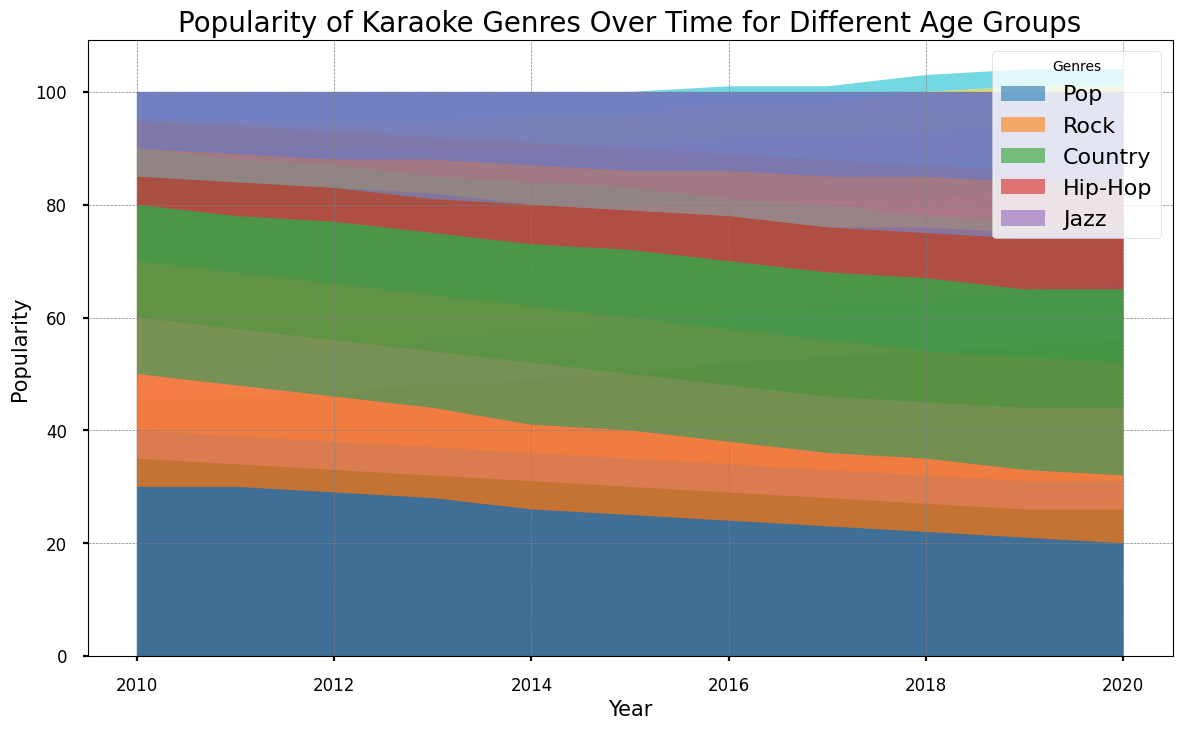What genre is most popular among the 25-34 age group in the year 2020? The genre that has the largest area within the segment for the 25-34 age group in 2020 is the most popular. By checking the stacked area, Pop has the largest representation.
Answer: Pop How did Pop's popularity change for the 18-24 age group from 2010 to 2020? By looking at the height of the Pop segment for the 18-24 age group in 2010 and comparing it to 2020, we see that it increased from approximately 50 to 66.
Answer: Increased Which age group showed the highest popularity for Jazz in 2020? By examining the segments for Jazz in 2020 across all age groups, the 55+ age group has the tallest Jazz segment.
Answer: 55+ What is the combined popularity of Rock and Country for the 35-44 age group in 2015? Add the heights of Rock and Country for the 35-44 age group in 2015. Rock is about 25 and Country is about 23, giving a total of 48.
Answer: 48 Which genre showed the least variation in popularity across all age groups from 2010 to 2020? Look at the areas of all genres over the years. Hip-Hop seems to have the most consistent, least varying area across all age groups and years.
Answer: Hip-Hop Compare the change in Rock's popularity for the 45-54 age group from 2010 to 2020 to the 55+ age group. In 2010, Rock popularity for 45-54 was about 25, and in 2020 it was about 18, a decrease of 7. For the 55+ age group, it went from 20 in 2010 to 12 in 2020, a decrease of 8.
Answer: Decrease was larger in 55+ How does the total popularity of Country in 2020 compare to 2010 for all age groups combined? Calculate the area sizes for Country across all age groups in 2010 and 2020. Sum them up (approximated visually). 2010: 10+10+20+25+30 = 95, 2020: 7+12+25+31+33 = 108.
Answer: Increased Which age group experienced the largest increase in Pop's popularity from 2010 to 2020? By looking at the change in height of the Pop segment from 2010 to 2020, the 18-24 age group increased from approximately 50 to 66, the highest increase among all groups.
Answer: 18-24 What is the trend of Jazz's popularity for the age group 55+ from 2010 to 2020? By examining the height of the Jazz segment for the 55+ age group, Jazz popularity consistently increases from about 15 in 2010 to 26 in 2020.
Answer: Consistently increasing Which genre shows the most significant upward trend for the 35-44 age group from 2010 to 2020? By evaluating the trend lines for all genres within the 35-44 age group, Pop shows the most significant upward trend from approximately 40 to 31.
Answer: Pop 